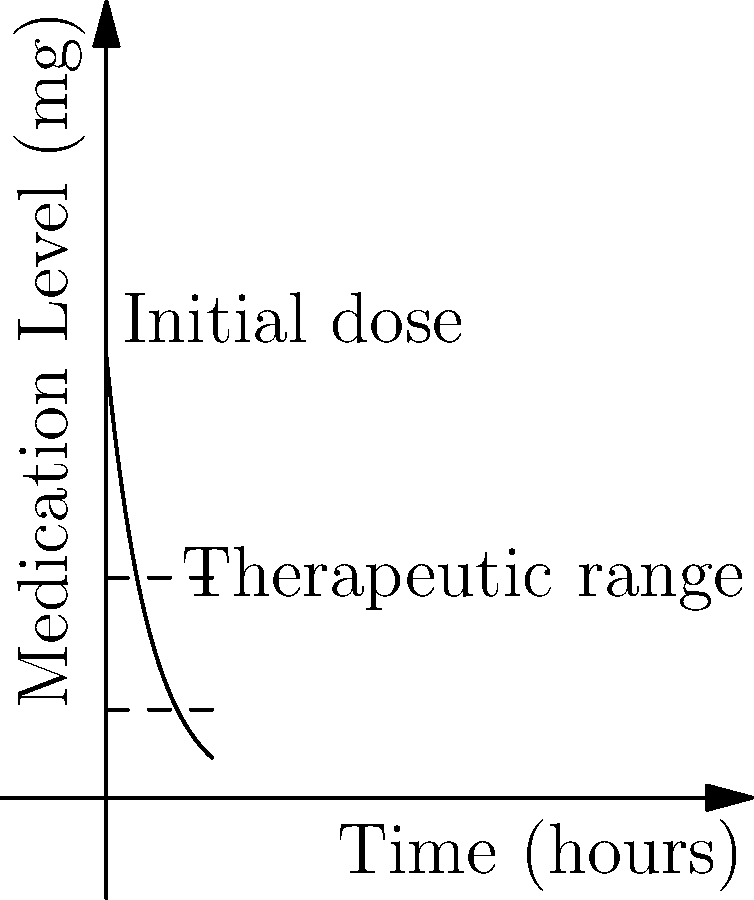As the primary caregiver for your parents, you're responsible for managing their medication schedule. The graph shows the concentration of a particular medication in the bloodstream over time. The therapeutic range is between 20mg and 50mg. If the initial dose is 100mg, after how many hours will the medication level first drop below the therapeutic range? To solve this problem, we need to follow these steps:

1) The medication level is given by the function $f(x) = 100e^{-0.1x}$, where $x$ is time in hours.

2) The lower bound of the therapeutic range is 20mg. We need to find when $f(x) = 20$.

3) Set up the equation:
   $100e^{-0.1x} = 20$

4) Divide both sides by 100:
   $e^{-0.1x} = 0.2$

5) Take the natural log of both sides:
   $\ln(e^{-0.1x}) = \ln(0.2)$
   $-0.1x = \ln(0.2)$

6) Solve for $x$:
   $x = -\frac{\ln(0.2)}{0.1} \approx 16.1$ hours

Therefore, the medication level will drop below the therapeutic range after approximately 16.1 hours.
Answer: 16.1 hours 